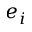<formula> <loc_0><loc_0><loc_500><loc_500>e _ { i }</formula> 